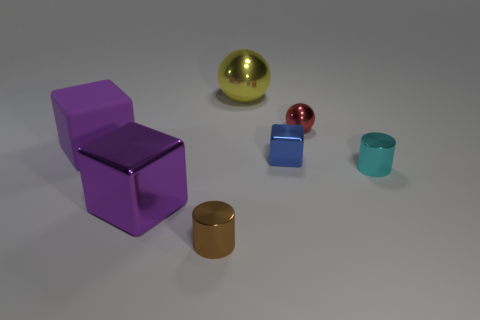Is there a small object of the same color as the large metallic sphere?
Ensure brevity in your answer.  No. How big is the cube to the right of the metallic block left of the cylinder that is left of the small metal ball?
Keep it short and to the point. Small. There is a small brown object; is its shape the same as the cyan metallic thing that is in front of the red sphere?
Make the answer very short. Yes. What number of other things are the same size as the blue shiny object?
Ensure brevity in your answer.  3. There is a cylinder right of the brown metallic cylinder; what size is it?
Offer a terse response. Small. How many small yellow blocks have the same material as the yellow object?
Offer a terse response. 0. Is the shape of the big yellow metallic object that is on the left side of the cyan cylinder the same as  the red thing?
Provide a succinct answer. Yes. There is a purple object that is in front of the large rubber block; what shape is it?
Make the answer very short. Cube. The other cube that is the same color as the big matte block is what size?
Your response must be concise. Large. What is the small red sphere made of?
Your response must be concise. Metal. 